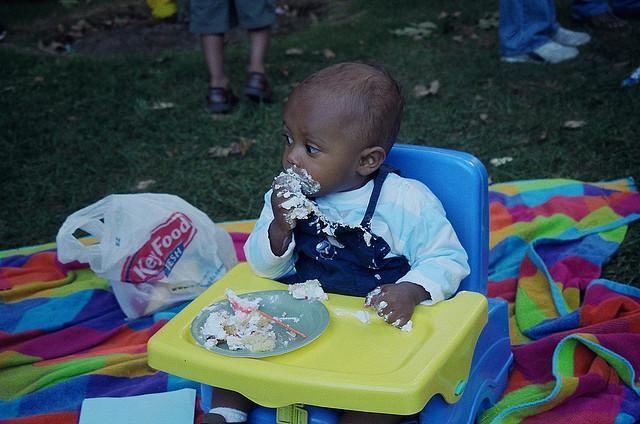How many chairs are in the picture?
Give a very brief answer. 1. How many cakes are visible?
Give a very brief answer. 1. How many people can you see?
Give a very brief answer. 3. How many cars coming toward us?
Give a very brief answer. 0. 